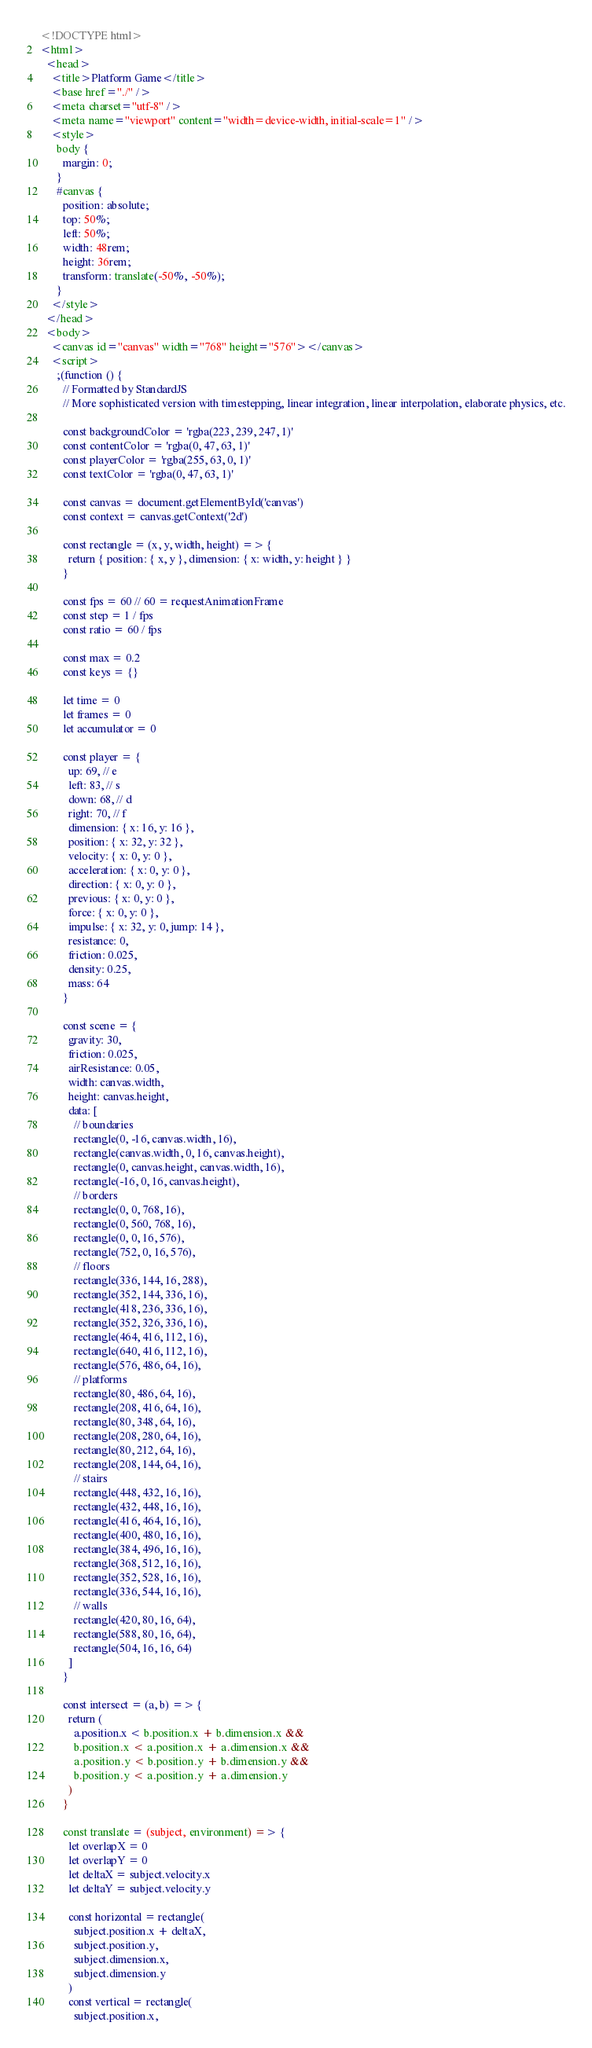Convert code to text. <code><loc_0><loc_0><loc_500><loc_500><_HTML_><!DOCTYPE html>
<html>
  <head>
    <title>Platform Game</title>
    <base href="./" />
    <meta charset="utf-8" />
    <meta name="viewport" content="width=device-width, initial-scale=1" />
    <style>
      body {
        margin: 0;
      }
      #canvas {
        position: absolute;
        top: 50%;
        left: 50%;
        width: 48rem;
        height: 36rem;
        transform: translate(-50%, -50%);
      }
    </style>
  </head>
  <body>
    <canvas id="canvas" width="768" height="576"></canvas>
    <script>
      ;(function () {
        // Formatted by StandardJS
        // More sophisticated version with timestepping, linear integration, linear interpolation, elaborate physics, etc.

        const backgroundColor = 'rgba(223, 239, 247, 1)'
        const contentColor = 'rgba(0, 47, 63, 1)'
        const playerColor = 'rgba(255, 63, 0, 1)'
        const textColor = 'rgba(0, 47, 63, 1)'

        const canvas = document.getElementById('canvas')
        const context = canvas.getContext('2d')

        const rectangle = (x, y, width, height) => {
          return { position: { x, y }, dimension: { x: width, y: height } }
        }

        const fps = 60 // 60 = requestAnimationFrame
        const step = 1 / fps
        const ratio = 60 / fps

        const max = 0.2
        const keys = {}

        let time = 0
        let frames = 0
        let accumulator = 0

        const player = {
          up: 69, // e
          left: 83, // s
          down: 68, // d
          right: 70, // f
          dimension: { x: 16, y: 16 },
          position: { x: 32, y: 32 },
          velocity: { x: 0, y: 0 },
          acceleration: { x: 0, y: 0 },
          direction: { x: 0, y: 0 },
          previous: { x: 0, y: 0 },
          force: { x: 0, y: 0 },
          impulse: { x: 32, y: 0, jump: 14 },
          resistance: 0,
          friction: 0.025,
          density: 0.25,
          mass: 64
        }

        const scene = {
          gravity: 30,
          friction: 0.025,
          airResistance: 0.05,
          width: canvas.width,
          height: canvas.height,
          data: [
            // boundaries
            rectangle(0, -16, canvas.width, 16),
            rectangle(canvas.width, 0, 16, canvas.height),
            rectangle(0, canvas.height, canvas.width, 16),
            rectangle(-16, 0, 16, canvas.height),
            // borders
            rectangle(0, 0, 768, 16),
            rectangle(0, 560, 768, 16),
            rectangle(0, 0, 16, 576),
            rectangle(752, 0, 16, 576),
            // floors
            rectangle(336, 144, 16, 288),
            rectangle(352, 144, 336, 16),
            rectangle(418, 236, 336, 16),
            rectangle(352, 326, 336, 16),
            rectangle(464, 416, 112, 16),
            rectangle(640, 416, 112, 16),
            rectangle(576, 486, 64, 16),
            // platforms
            rectangle(80, 486, 64, 16),
            rectangle(208, 416, 64, 16),
            rectangle(80, 348, 64, 16),
            rectangle(208, 280, 64, 16),
            rectangle(80, 212, 64, 16),
            rectangle(208, 144, 64, 16),
            // stairs
            rectangle(448, 432, 16, 16),
            rectangle(432, 448, 16, 16),
            rectangle(416, 464, 16, 16),
            rectangle(400, 480, 16, 16),
            rectangle(384, 496, 16, 16),
            rectangle(368, 512, 16, 16),
            rectangle(352, 528, 16, 16),
            rectangle(336, 544, 16, 16),
            // walls
            rectangle(420, 80, 16, 64),
            rectangle(588, 80, 16, 64),
            rectangle(504, 16, 16, 64)
          ]
        }

        const intersect = (a, b) => {
          return (
            a.position.x < b.position.x + b.dimension.x &&
            b.position.x < a.position.x + a.dimension.x &&
            a.position.y < b.position.y + b.dimension.y &&
            b.position.y < a.position.y + a.dimension.y
          )
        }

        const translate = (subject, environment) => {
          let overlapX = 0
          let overlapY = 0
          let deltaX = subject.velocity.x
          let deltaY = subject.velocity.y

          const horizontal = rectangle(
            subject.position.x + deltaX,
            subject.position.y,
            subject.dimension.x,
            subject.dimension.y
          )
          const vertical = rectangle(
            subject.position.x,</code> 